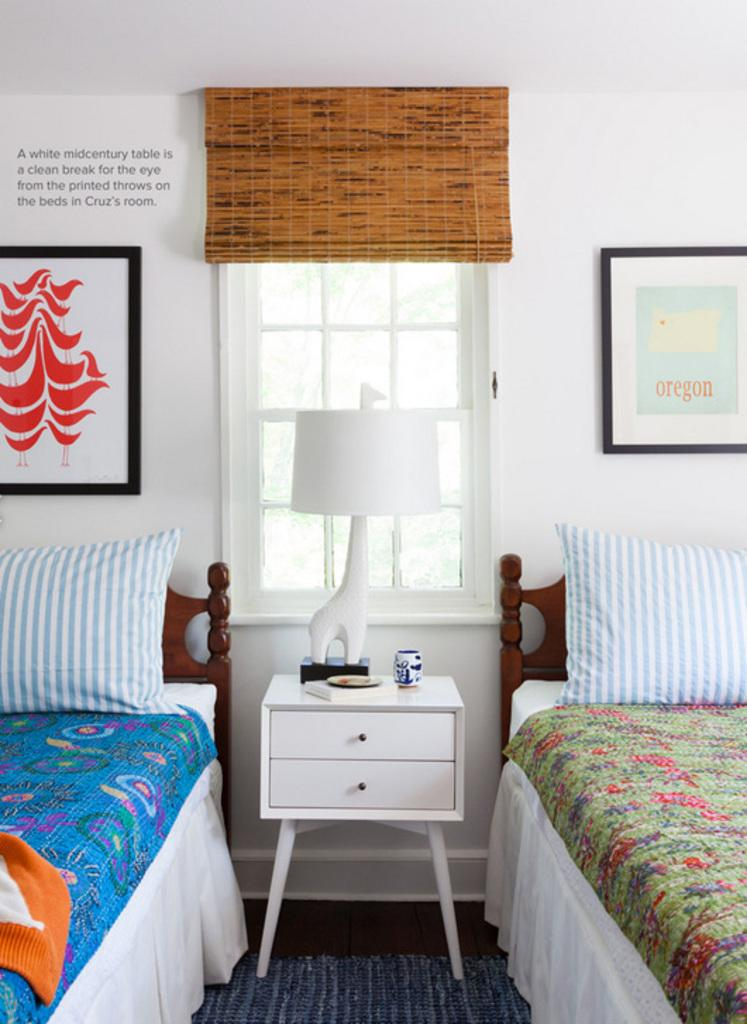How many beds are visible in the image? There are 2 beds in the image. What is placed on the beds for comfort? There are 2 pillows in the image. What type of furniture is present in the image for storage? There is a drawer in the image. What type of lighting is available in the room? There is a lamp in the image. What allows natural light to enter the room? There is a window in the image. What type of structure surrounds the room? There is a wall in the image. What type of decoration is attached to the wall? There are 2 photo frames attached to the wall in the image. What color is the orange hanging from the ceiling in the image? There is no orange present in the image; it only features beds, pillows, a drawer, a lamp, a window, a wall, and photo frames. How many astronauts can be seen exploring the room in the image? There are no astronauts or any reference to space in the image; it is an indoor room with furniture and decorations. 